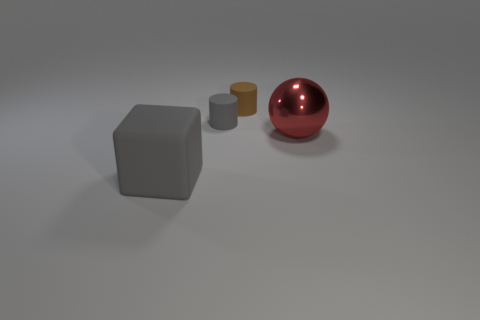What materials do the objects appear to be made of? The cube appears to have a matte surface, suggesting it could be made of a material such as plastic or stone. The small gray and brown cylinders seem to have a metallic sheen, perhaps made of metal. The large red sphere has a reflective glossy finish that indicates it might be made of polished metal or glass. 